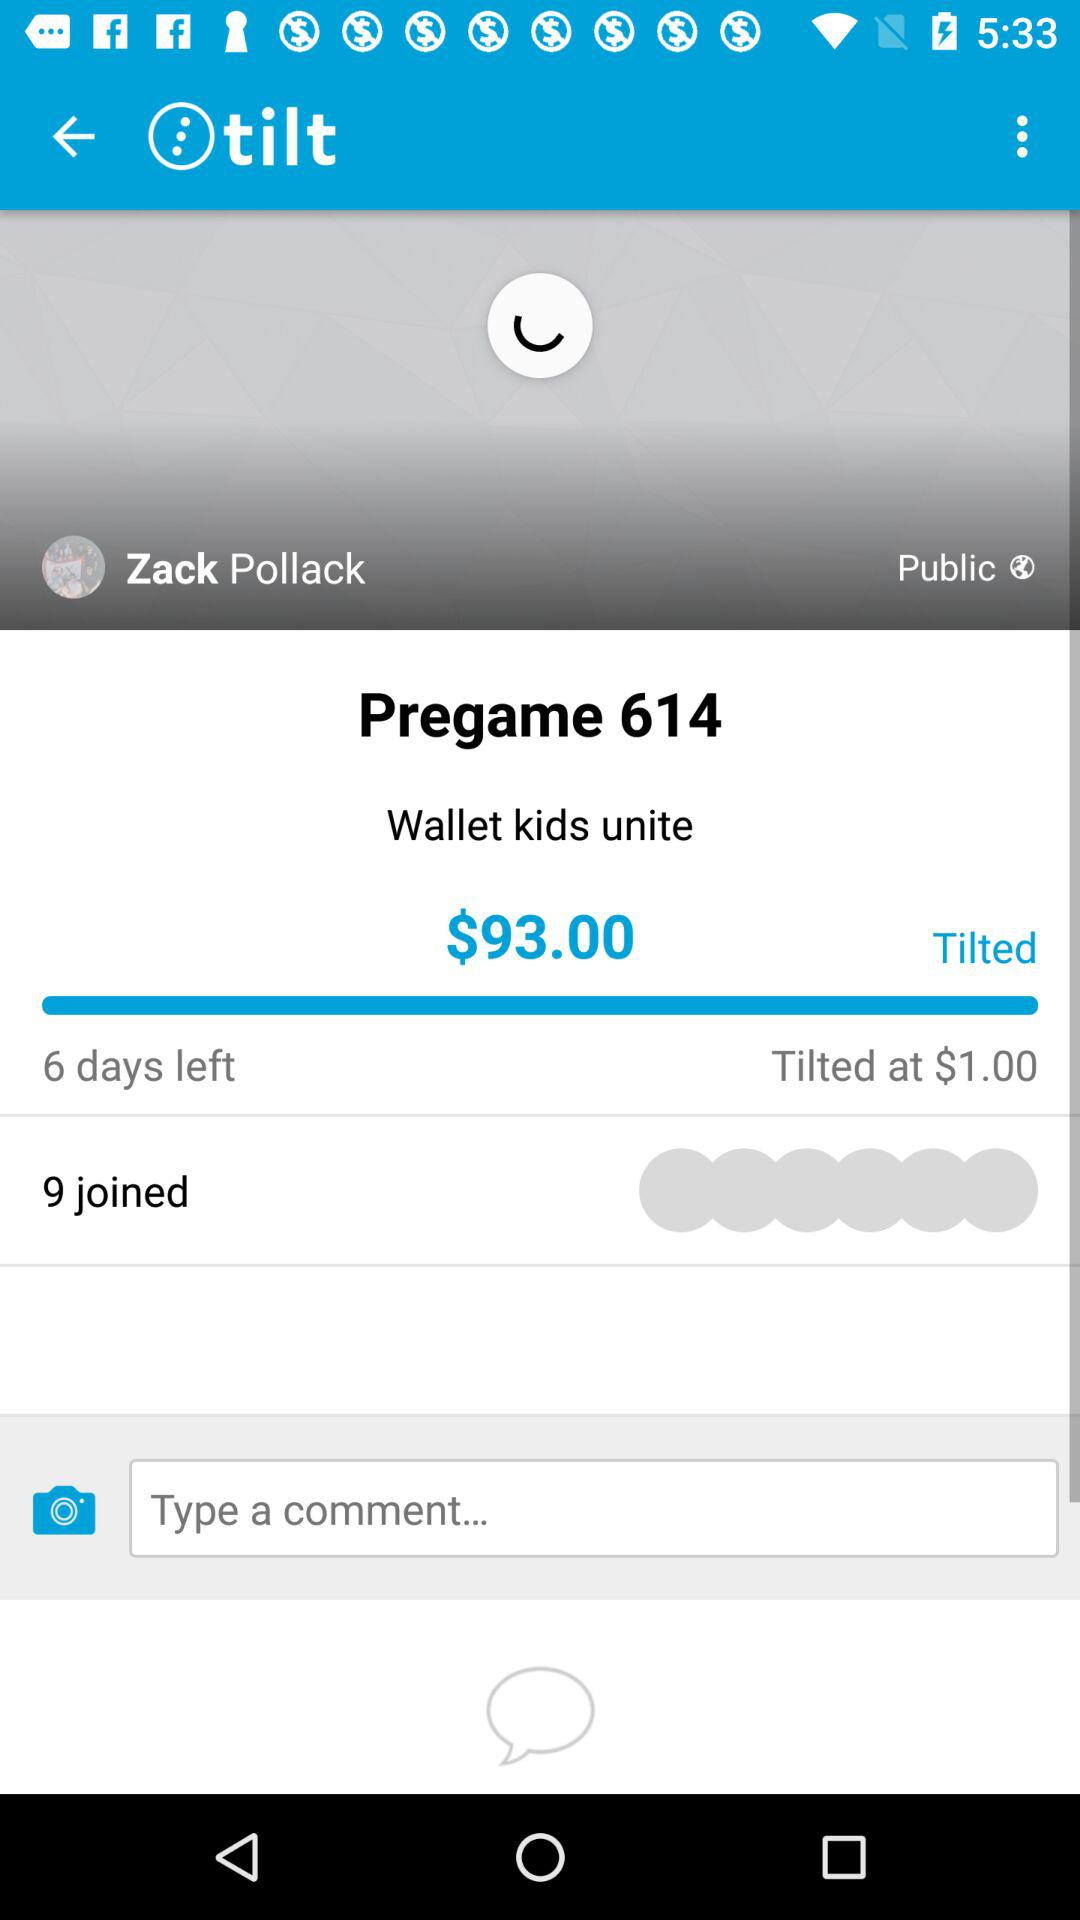How much money has been donated to the tilt?
Answer the question using a single word or phrase. $93.00 